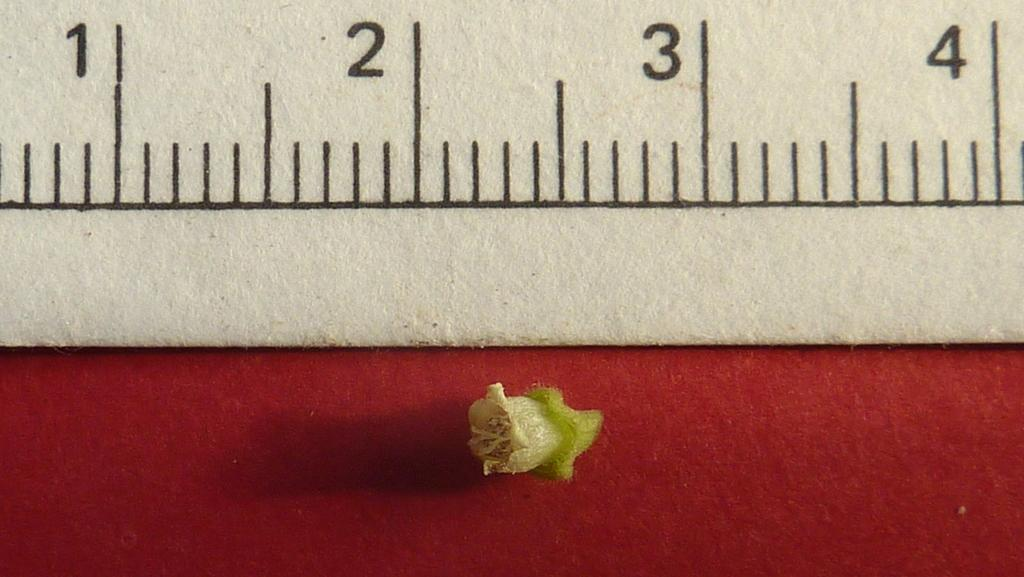<image>
Create a compact narrative representing the image presented. An object is placed between the 2 and 3 demarcations on a ruler. 